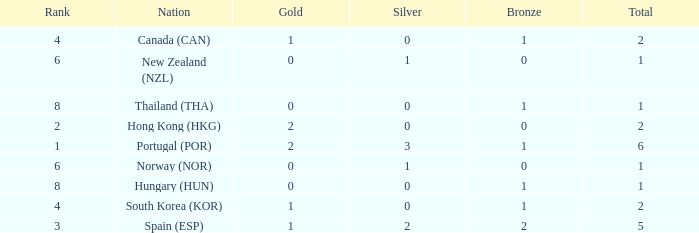What is the lowest Total containing a Bronze of 0 and Rank smaller than 2? None. 